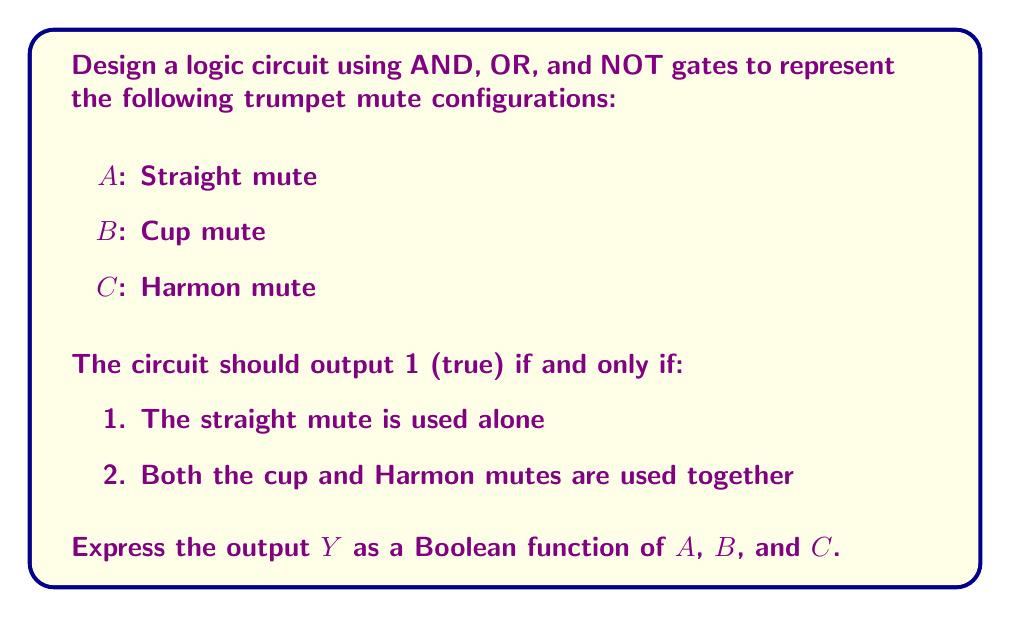Can you solve this math problem? Let's approach this step-by-step:

1) First, we need to identify the conditions for the output to be true:
   - Condition 1: A is true, B and C are false
   - Condition 2: B and C are true, A is false

2) We can express these conditions using Boolean algebra:
   - Condition 1: $A \cdot \overline{B} \cdot \overline{C}$
   - Condition 2: $\overline{A} \cdot B \cdot C$

3) The output Y should be true if either of these conditions is true. We can represent this using the OR operation:

   $Y = (A \cdot \overline{B} \cdot \overline{C}) + (\overline{A} \cdot B \cdot C)$

4) This Boolean function can be implemented using AND, OR, and NOT gates:
   - We need two AND gates with three inputs each
   - We need one OR gate with two inputs
   - We need three NOT gates (for $\overline{A}$, $\overline{B}$, and $\overline{C}$)

5) The circuit would look like this:

[asy]
unitsize(1cm);

// Input labels
label("A", (-1,3));
label("B", (-1,2));
label("C", (-1,1));

// NOT gates
draw((-0.5,3)--(-0.5,3.5)--(0.5,3.5)--(0.5,3)--(-0.5,3));
draw((0,3)--(0.25,3));
draw((-0.5,2)--(-0.5,2.5)--(0.5,2.5)--(0.5,2)--(-0.5,2));
draw((0,2)--(0.25,2));
draw((-0.5,1)--(-0.5,1.5)--(0.5,1.5)--(0.5,1)--(-0.5,1));
draw((0,1)--(0.25,1));

// AND gates
draw((1,2.5)--(1,3.5)--(2,3.5)--(2,2.5)--cycle);
label("AND", (1.5,3));
draw((1,0.5)--(1,1.5)--(2,1.5)--(2,0.5)--cycle);
label("AND", (1.5,1));

// OR gate
draw((3,1.5)--(3,2.5)--(4,2.5)--(4,1.5)--cycle);
label("OR", (3.5,2));

// Connections
draw((-1,3)--(0.6,3)--(0.6,3.25)--(1,3.25));
draw((-1,2)--(-0.5,2));
draw((0.5,2)--(0.75,2)--(0.75,3)--(1,3));
draw((-1,1)--(-0.5,1));
draw((0.5,1)--(0.75,1)--(0.75,2.75)--(1,2.75));
draw((0.5,3)--(0.6,3));
draw((0.25,2)--(0.75,2));
draw((0.25,1)--(0.75,1));
draw((-1,2)--(-0.25,2)--(-0.25,1.25)--(1,1.25));
draw((-1,1)--(-0.25,1)--(-0.25,0.75)--(1,0.75));
draw((2,3)--(2.5,3)--(2.5,2.25)--(3,2.25));
draw((2,1)--(2.5,1)--(2.5,1.75)--(3,1.75));
draw((4,2)--(4.5,2));
label("Y", (4.5,2));
[/asy]

This circuit implements the Boolean function we derived.
Answer: $Y = (A \cdot \overline{B} \cdot \overline{C}) + (\overline{A} \cdot B \cdot C)$ 